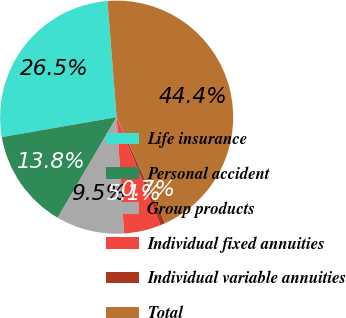Convert chart to OTSL. <chart><loc_0><loc_0><loc_500><loc_500><pie_chart><fcel>Life insurance<fcel>Personal accident<fcel>Group products<fcel>Individual fixed annuities<fcel>Individual variable annuities<fcel>Total<nl><fcel>26.48%<fcel>13.83%<fcel>9.46%<fcel>5.09%<fcel>0.72%<fcel>44.41%<nl></chart> 